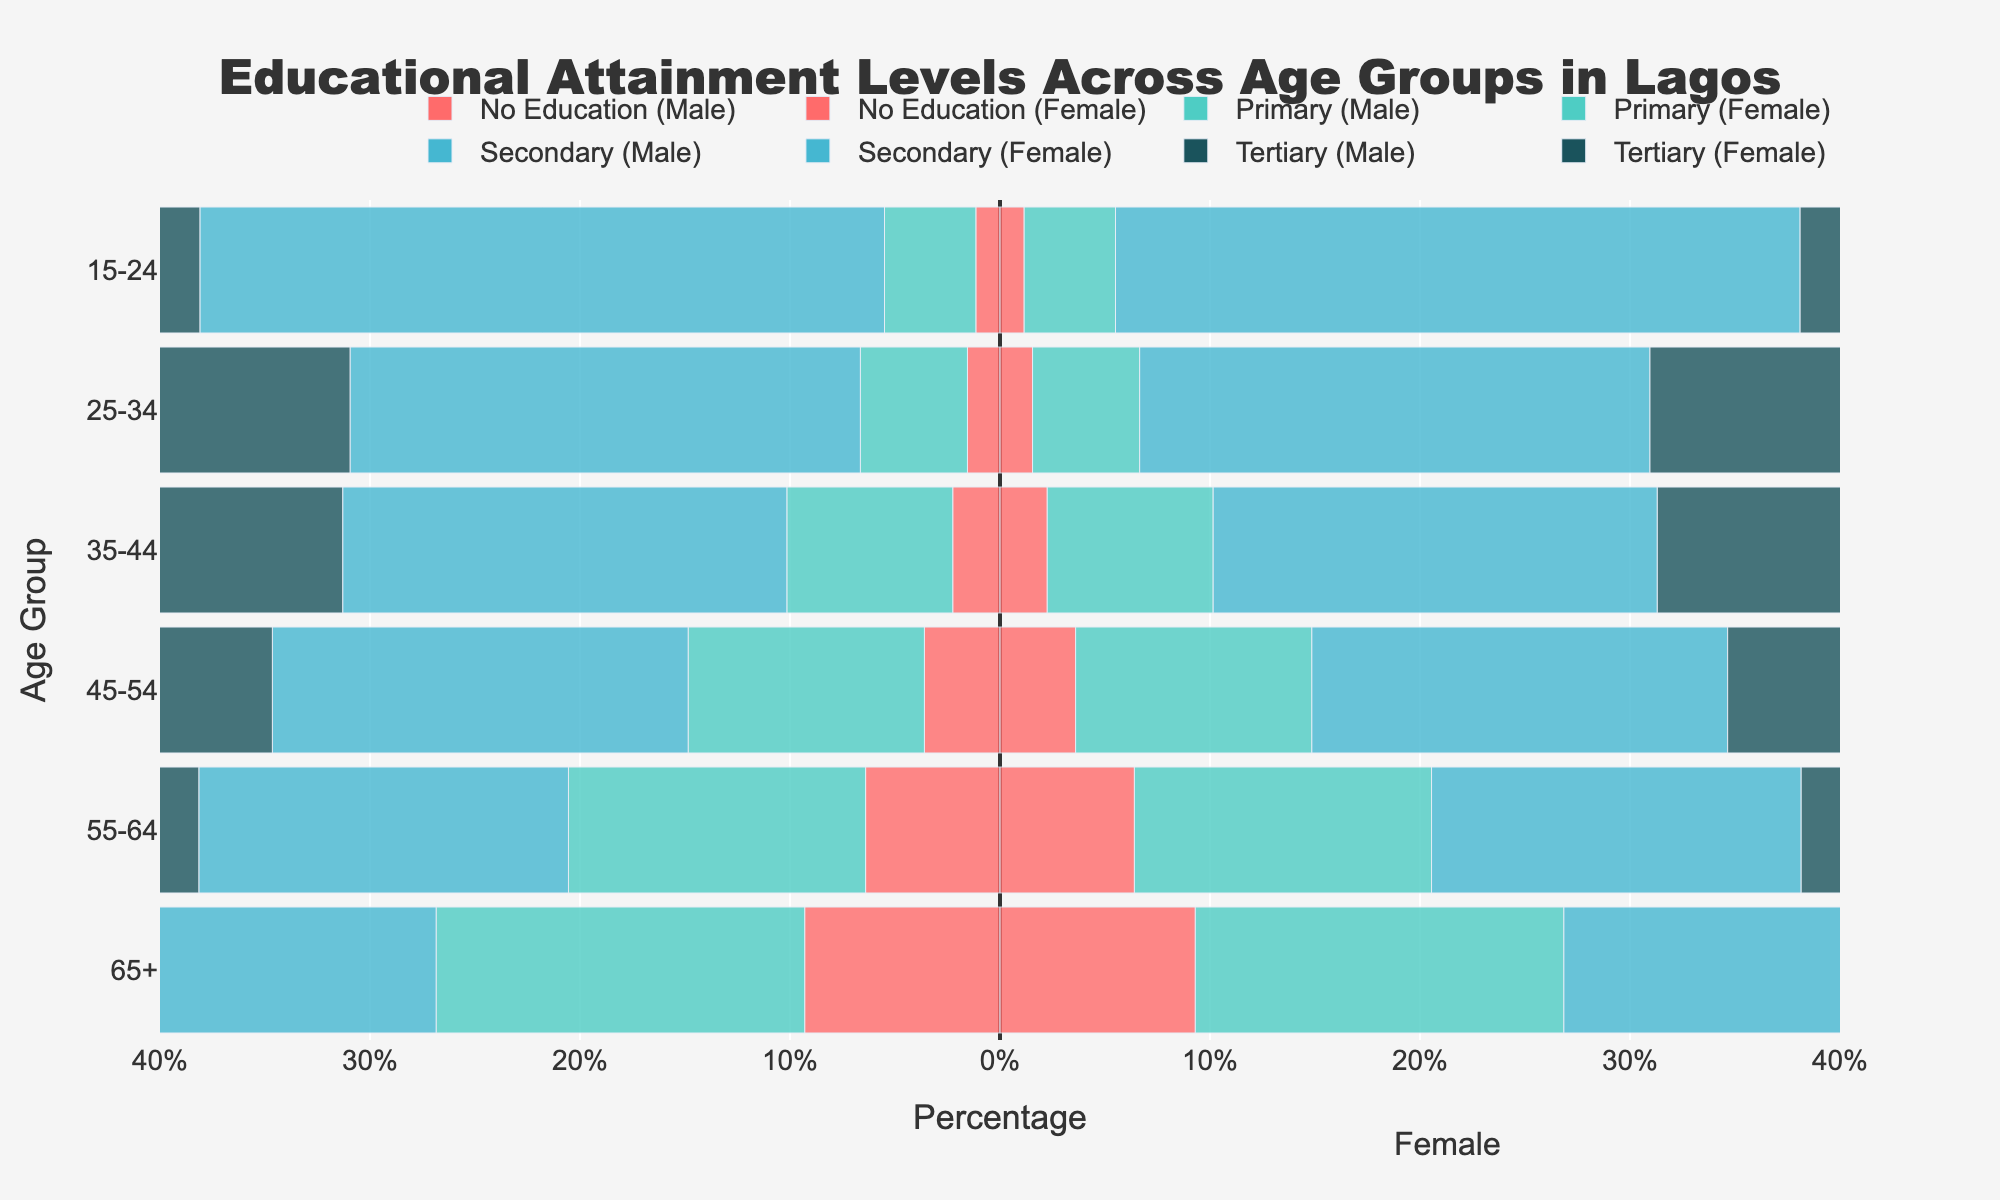What's the title of the figure? The title of the figure is usually located at the top. It's the largest text that stands out and summarizes the data being represented.
Answer: Educational Attainment Levels Across Age Groups in Lagos What age group has the highest percentage of tertiary education? Locate the bars for tertiary education and check which age group has the largest segment. This is identified by the length of the corresponding bar.
Answer: 25-34 Which age group has the highest percentage of people with no education? Look at the section for 'No Education' and identify the age group with the most extended bar for 'No Education'.
Answer: 65+ How does the percentage of primary education in the age group 45-54 compare with the age group 35-44? Locate the bars for primary education for these two age groups and compare their lengths.
Answer: The percentage is higher in the 45-54 age group What is the total percentage of people with secondary education in the age groups 25-34 and 35-44? Sum the percentages for secondary education for the age groups 25-34 (48.6%) and 35-44 (42.3%). Add 48.6% + 42.3%.
Answer: 90.9% Which age group has the smallest combined percentage for secondary and tertiary education? For each age group, add the percentages for secondary and tertiary education. Determine which group has the smallest total.
Answer: 65+ How does tertiary education change from the 45-54 age group to the 55-64 age group? Compare the length of the tertiary education bars for the 45-54 and 55-64 age groups.
Answer: It decreases What's the percentage difference in no education between the youngest (15-24) and oldest (65+) age groups? Subtract the percentage of the 15-24 age group (2.3%) from the 65+ age group (18.6%). Calculate 18.6% - 2.3%.
Answer: 16.3% 